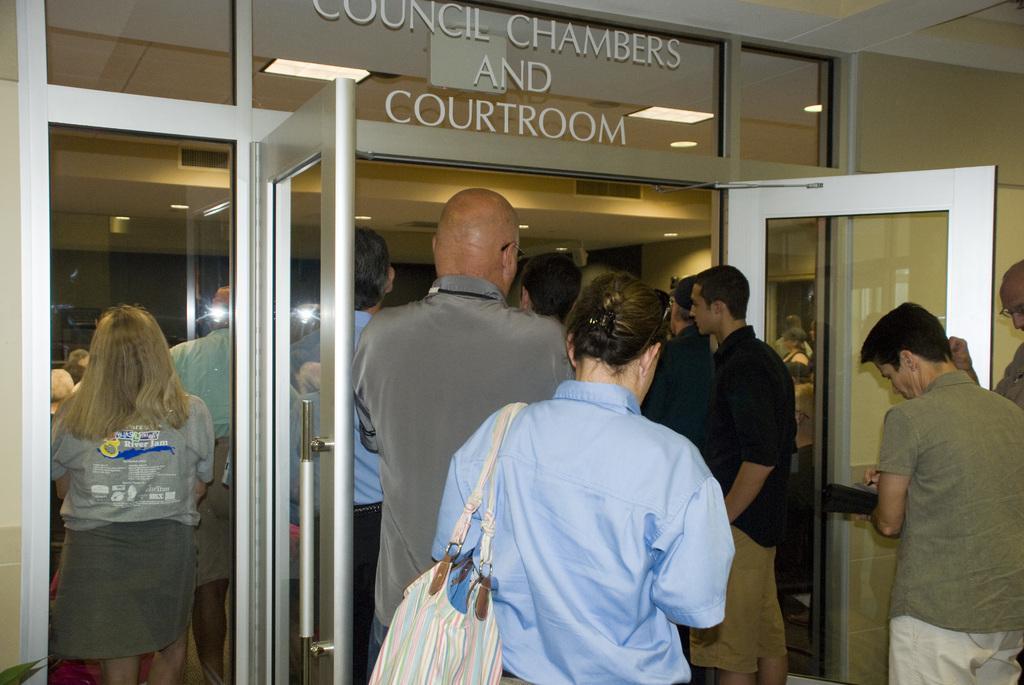Describe this image in one or two sentences. Here we see a room with group of people standing and a woman wearing a handbag and sunglasses on her head 